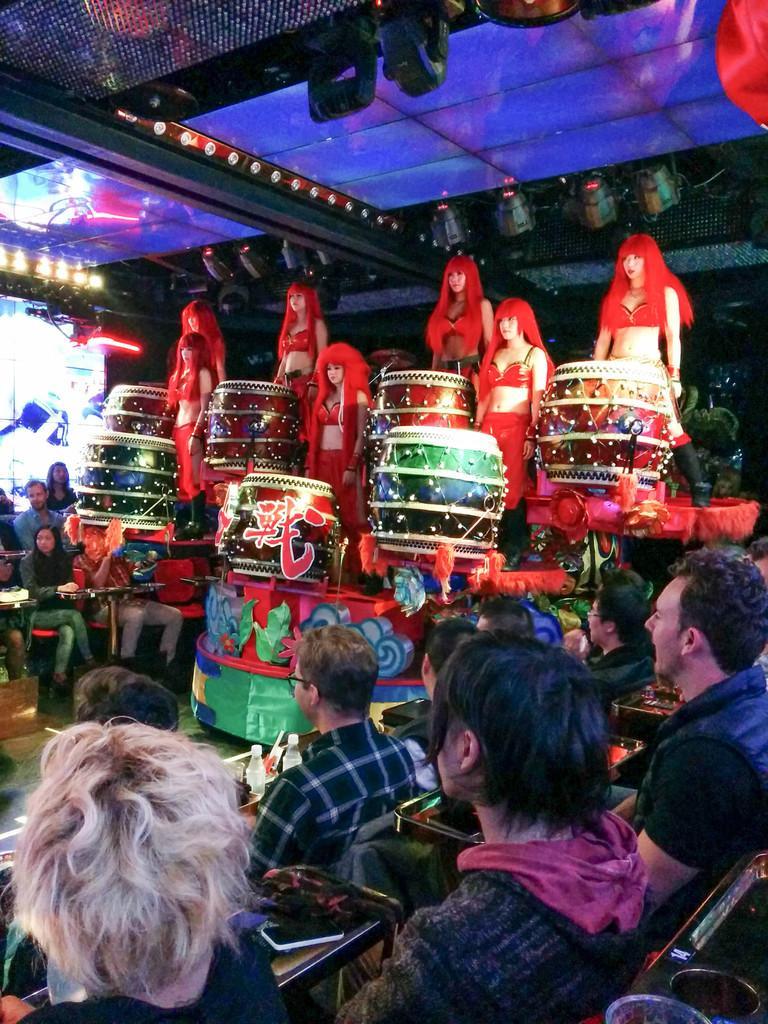Please provide a concise description of this image. In this image I see number of people and I see few women over here who are wearing same dress and I see the drums in front of them and I see most of the people are sitting and in the background I see the lights over here and it is a bit dark over here. 